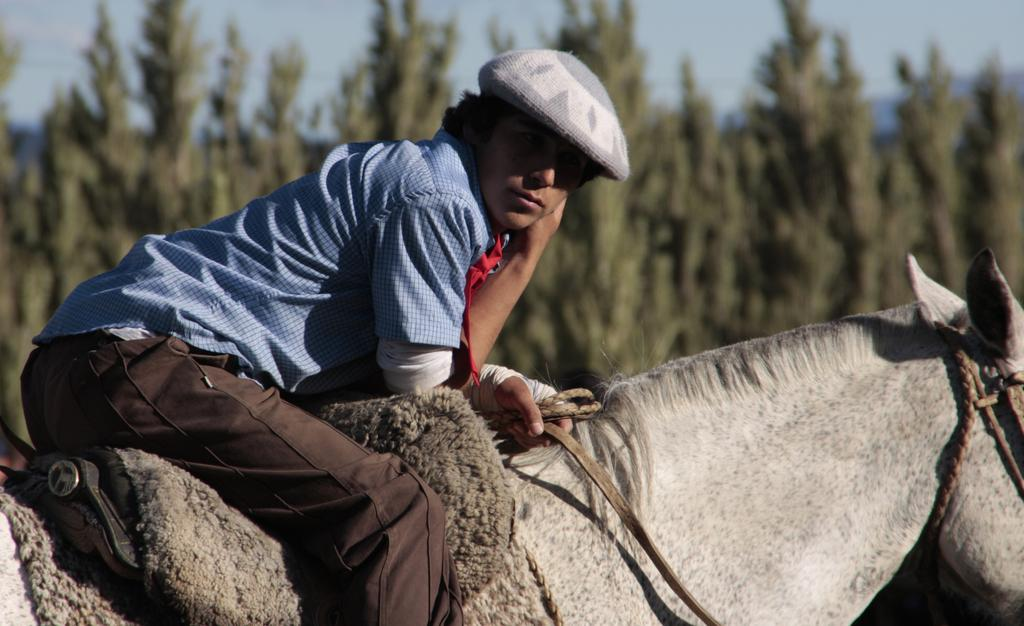Who is the main subject in the image? There is a man in the image. What is the man doing in the image? The man is sitting on a horse. What is the man wearing on his head? The man is wearing a cap. What can be seen in the background of the image? There are trees in the background of the image. What type of pear is the man holding in the image? There is no pear present in the image; the man is sitting on a horse and wearing a cap. Is there a band playing music in the background of the image? There is no band present in the image; the background features trees. 